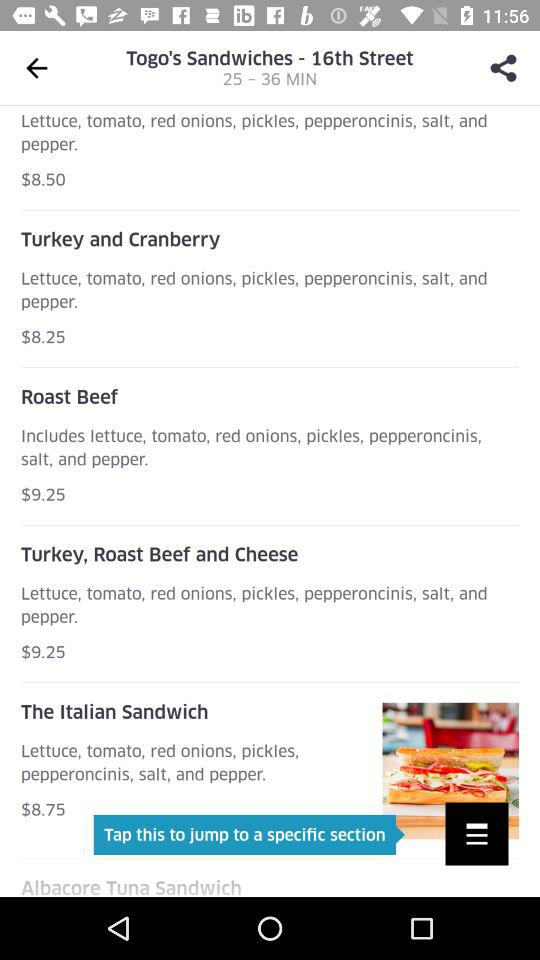What ingredients are used in the "Turkey and Cranberry" recipe? The ingredients are lettuce, tomato, red onions, pickles, pepperoncinis, salt, and pepper. 